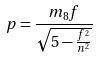<formula> <loc_0><loc_0><loc_500><loc_500>p = \frac { m _ { 8 } f } { \sqrt { 5 - \frac { f ^ { 2 } } { n ^ { 2 } } } }</formula> 